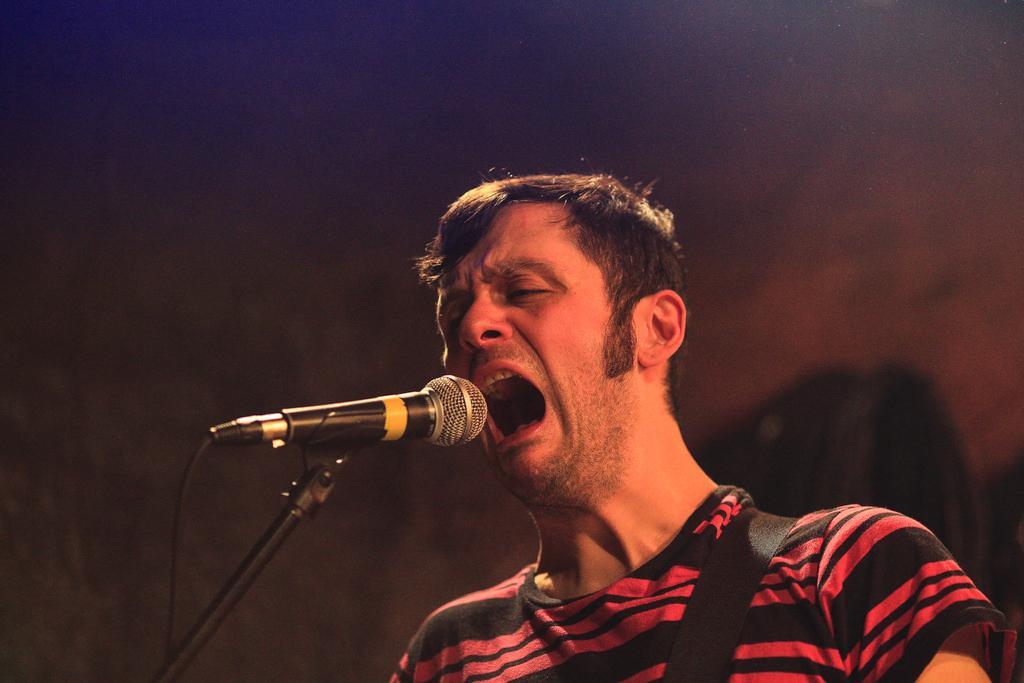Please provide a concise description of this image. This picture shows a man standing and singing with the help of a microphone. 